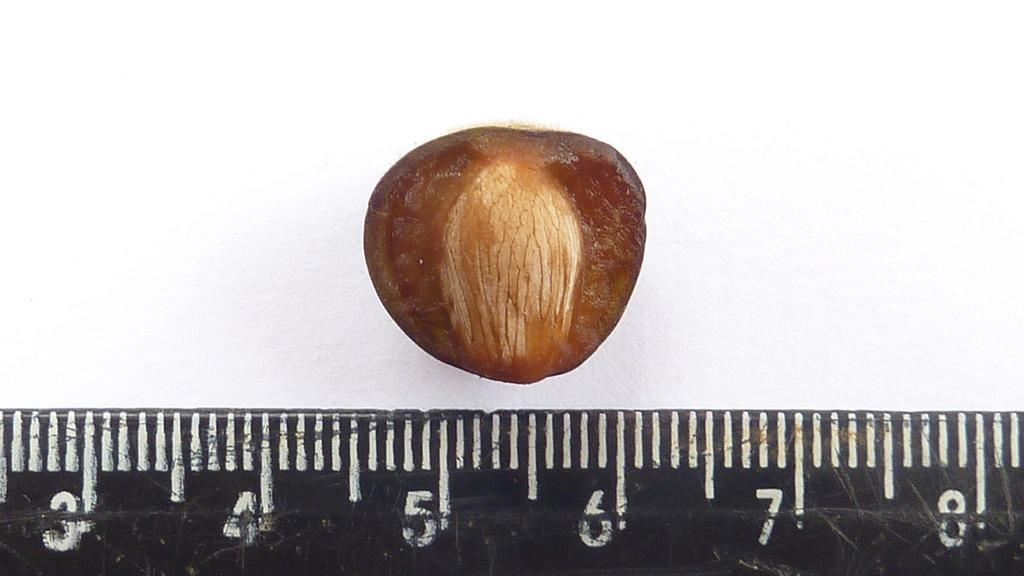<image>
Share a concise interpretation of the image provided. A brown nut measures around one inch across. 